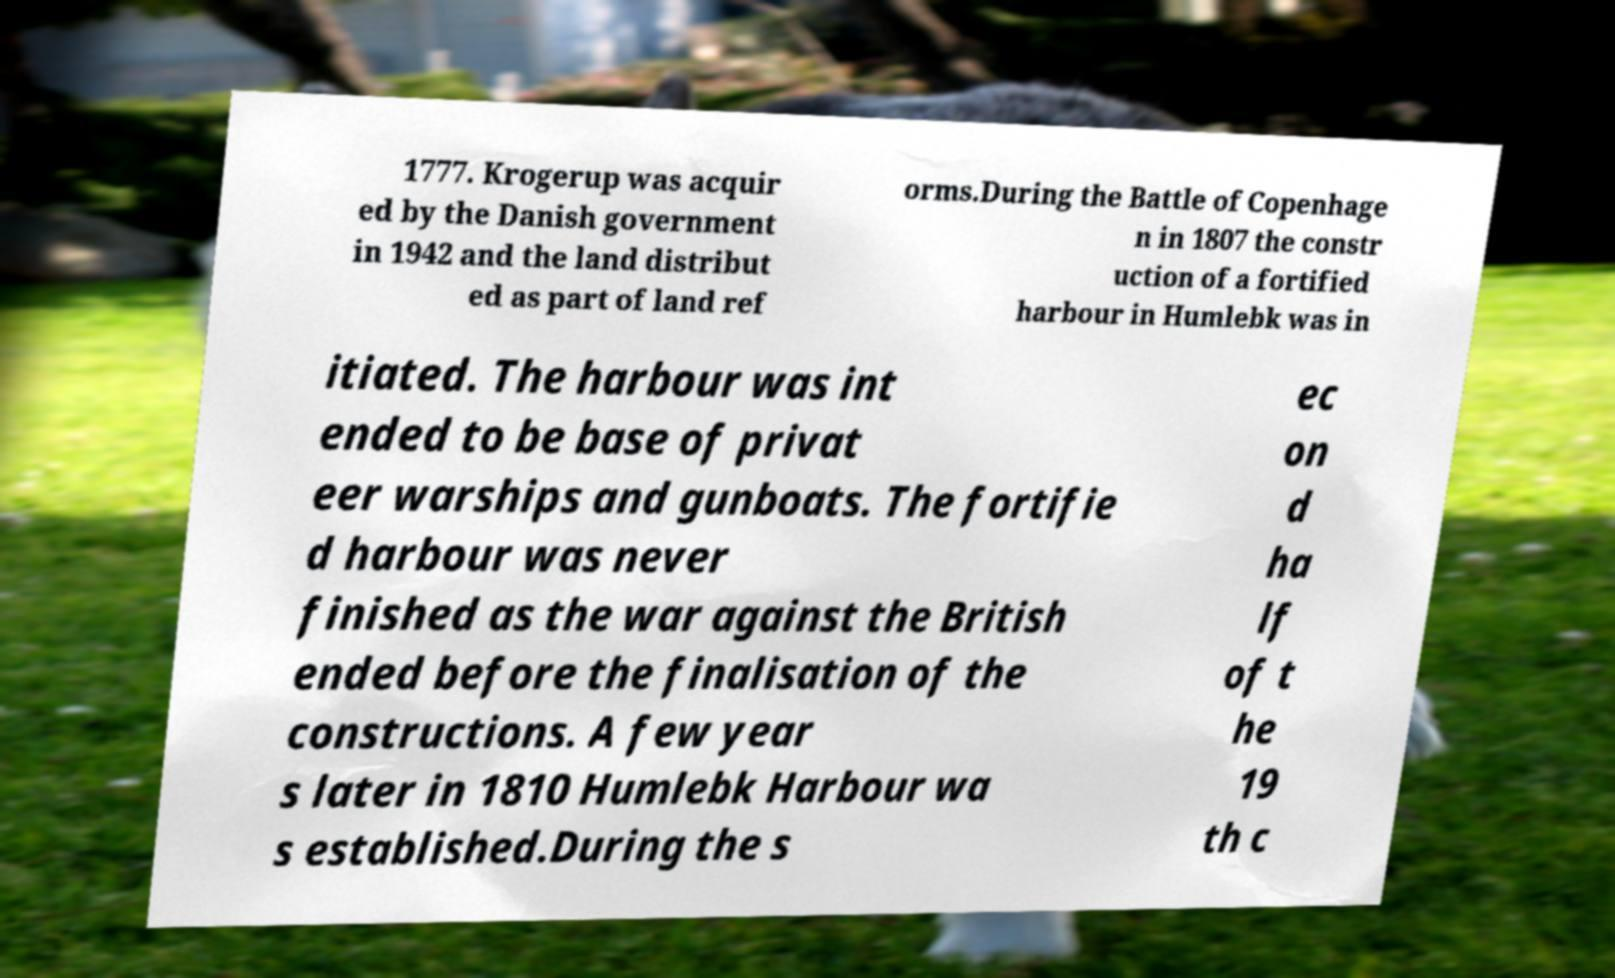There's text embedded in this image that I need extracted. Can you transcribe it verbatim? 1777. Krogerup was acquir ed by the Danish government in 1942 and the land distribut ed as part of land ref orms.During the Battle of Copenhage n in 1807 the constr uction of a fortified harbour in Humlebk was in itiated. The harbour was int ended to be base of privat eer warships and gunboats. The fortifie d harbour was never finished as the war against the British ended before the finalisation of the constructions. A few year s later in 1810 Humlebk Harbour wa s established.During the s ec on d ha lf of t he 19 th c 